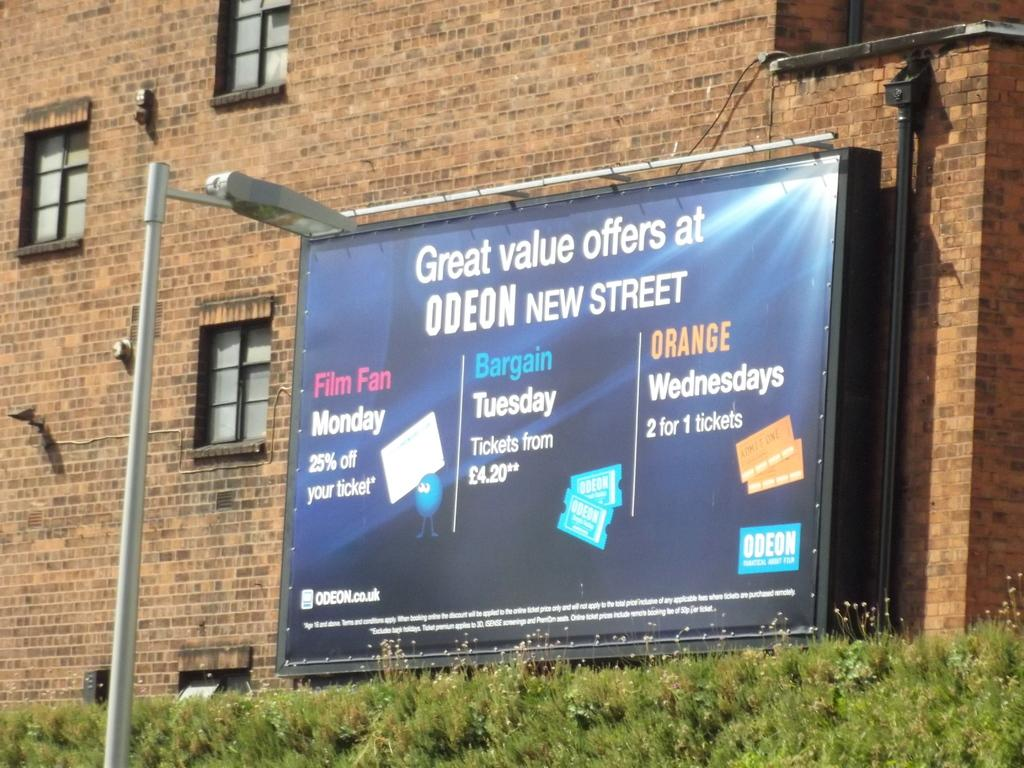<image>
Relay a brief, clear account of the picture shown. a billboard that says 'great value offers at odeon new street' on it 